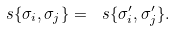Convert formula to latex. <formula><loc_0><loc_0><loc_500><loc_500>\ s \{ \sigma _ { i } , \sigma _ { j } \} = \ s \{ \sigma _ { i } ^ { \prime } , \sigma _ { j } ^ { \prime } \} .</formula> 